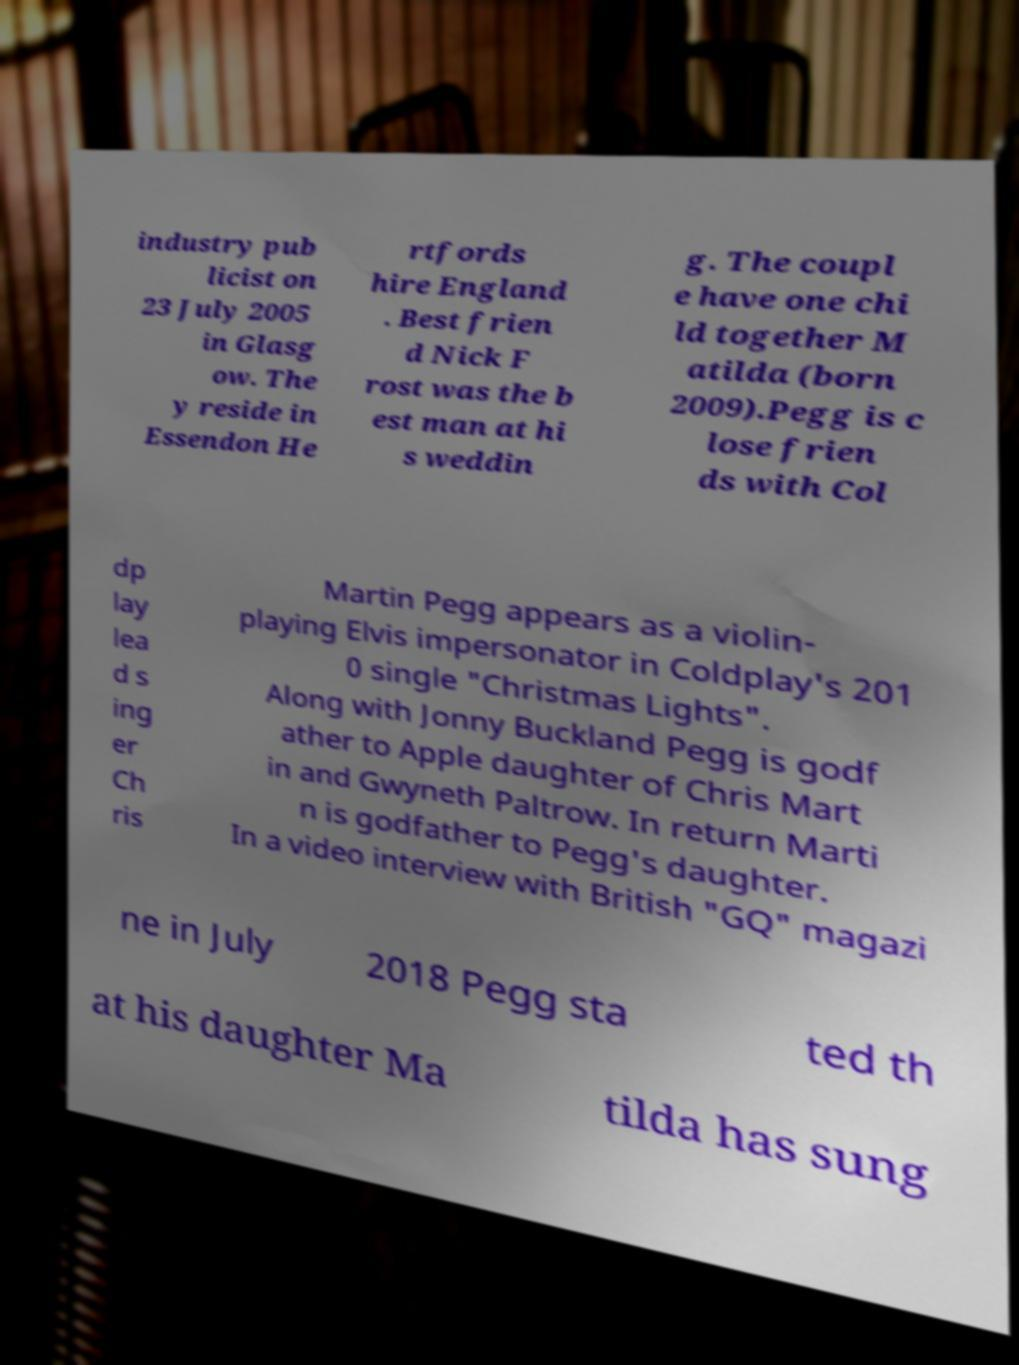Can you accurately transcribe the text from the provided image for me? industry pub licist on 23 July 2005 in Glasg ow. The y reside in Essendon He rtfords hire England . Best frien d Nick F rost was the b est man at hi s weddin g. The coupl e have one chi ld together M atilda (born 2009).Pegg is c lose frien ds with Col dp lay lea d s ing er Ch ris Martin Pegg appears as a violin- playing Elvis impersonator in Coldplay's 201 0 single "Christmas Lights". Along with Jonny Buckland Pegg is godf ather to Apple daughter of Chris Mart in and Gwyneth Paltrow. In return Marti n is godfather to Pegg's daughter. In a video interview with British "GQ" magazi ne in July 2018 Pegg sta ted th at his daughter Ma tilda has sung 